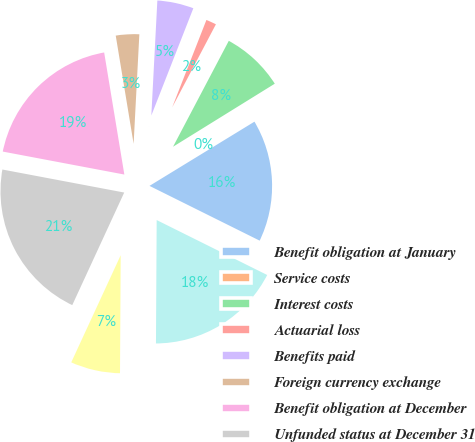<chart> <loc_0><loc_0><loc_500><loc_500><pie_chart><fcel>Benefit obligation at January<fcel>Service costs<fcel>Interest costs<fcel>Actuarial loss<fcel>Benefits paid<fcel>Foreign currency exchange<fcel>Benefit obligation at December<fcel>Unfunded status at December 31<fcel>Current liabilities<fcel>Non-current liabilities<nl><fcel>16.08%<fcel>0.09%<fcel>8.46%<fcel>1.77%<fcel>5.11%<fcel>3.44%<fcel>19.42%<fcel>21.09%<fcel>6.79%<fcel>17.75%<nl></chart> 